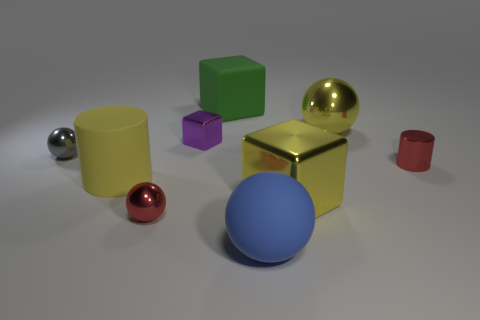What colors are the spherical objects in this image? The spherical objects come in three colors: gold, red, and silver.  Is the red sphere larger or smaller than the gold one? The red sphere is smaller than the gold one. 